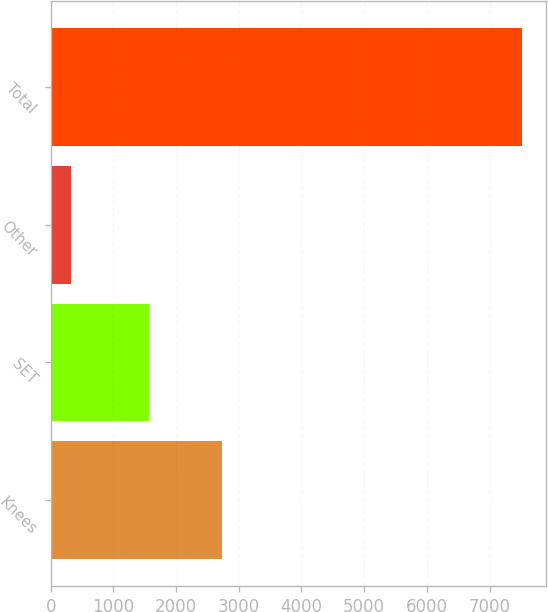<chart> <loc_0><loc_0><loc_500><loc_500><bar_chart><fcel>Knees<fcel>SET<fcel>Other<fcel>Total<nl><fcel>2735.9<fcel>1571.8<fcel>329.2<fcel>7517.8<nl></chart> 